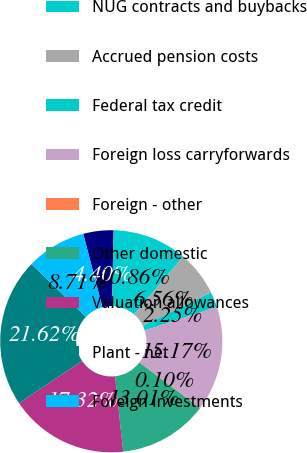Convert chart. <chart><loc_0><loc_0><loc_500><loc_500><pie_chart><fcel>Deferred investment tax<fcel>NUG contracts and buybacks<fcel>Accrued pension costs<fcel>Federal tax credit<fcel>Foreign loss carryforwards<fcel>Foreign - other<fcel>Other domestic<fcel>Valuation allowances<fcel>Plant - net<fcel>Foreign investments<nl><fcel>4.4%<fcel>10.86%<fcel>6.56%<fcel>2.25%<fcel>15.17%<fcel>0.1%<fcel>13.01%<fcel>17.32%<fcel>21.62%<fcel>8.71%<nl></chart> 